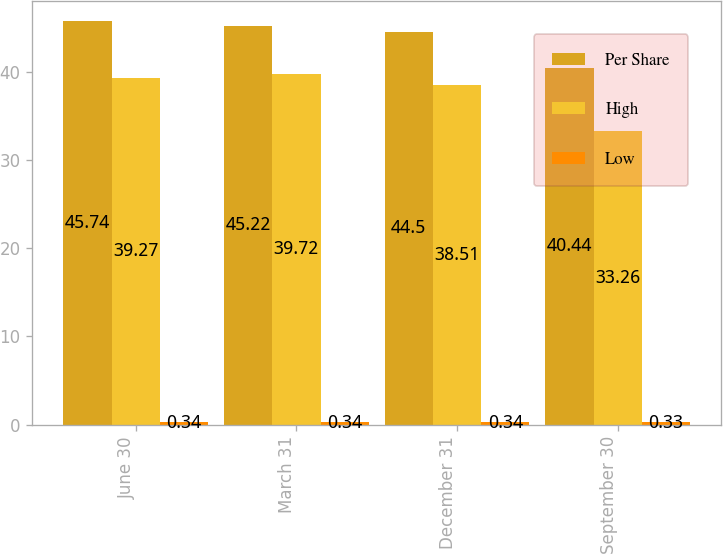Convert chart. <chart><loc_0><loc_0><loc_500><loc_500><stacked_bar_chart><ecel><fcel>June 30<fcel>March 31<fcel>December 31<fcel>September 30<nl><fcel>Per Share<fcel>45.74<fcel>45.22<fcel>44.5<fcel>40.44<nl><fcel>High<fcel>39.27<fcel>39.72<fcel>38.51<fcel>33.26<nl><fcel>Low<fcel>0.34<fcel>0.34<fcel>0.34<fcel>0.33<nl></chart> 